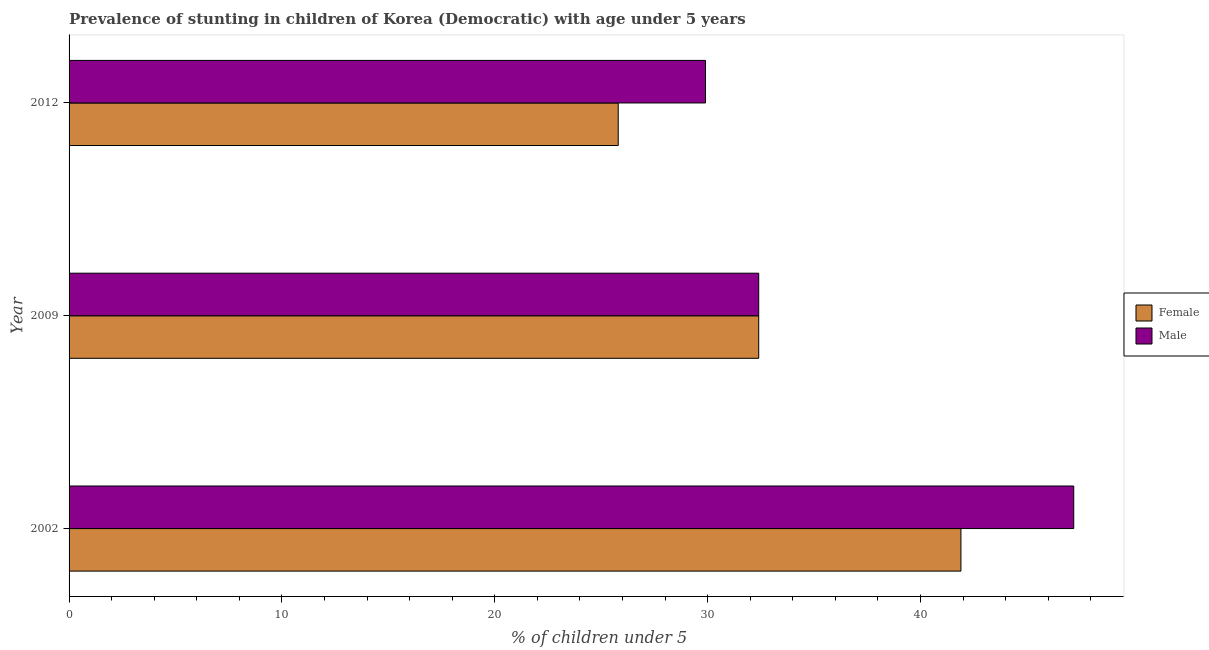How many groups of bars are there?
Keep it short and to the point. 3. Are the number of bars on each tick of the Y-axis equal?
Offer a very short reply. Yes. How many bars are there on the 2nd tick from the bottom?
Keep it short and to the point. 2. What is the label of the 1st group of bars from the top?
Offer a very short reply. 2012. In how many cases, is the number of bars for a given year not equal to the number of legend labels?
Your answer should be compact. 0. What is the percentage of stunted male children in 2009?
Offer a terse response. 32.4. Across all years, what is the maximum percentage of stunted female children?
Your answer should be very brief. 41.9. Across all years, what is the minimum percentage of stunted female children?
Ensure brevity in your answer.  25.8. In which year was the percentage of stunted male children maximum?
Keep it short and to the point. 2002. In which year was the percentage of stunted female children minimum?
Provide a succinct answer. 2012. What is the total percentage of stunted male children in the graph?
Your answer should be very brief. 109.5. What is the difference between the percentage of stunted male children in 2002 and that in 2012?
Your answer should be compact. 17.3. What is the difference between the percentage of stunted male children in 2009 and the percentage of stunted female children in 2012?
Your answer should be very brief. 6.6. What is the average percentage of stunted female children per year?
Offer a terse response. 33.37. What is the ratio of the percentage of stunted male children in 2002 to that in 2012?
Give a very brief answer. 1.58. Is the percentage of stunted female children in 2009 less than that in 2012?
Ensure brevity in your answer.  No. What is the difference between the highest and the second highest percentage of stunted male children?
Give a very brief answer. 14.8. What is the difference between the highest and the lowest percentage of stunted female children?
Give a very brief answer. 16.1. In how many years, is the percentage of stunted male children greater than the average percentage of stunted male children taken over all years?
Keep it short and to the point. 1. Is the sum of the percentage of stunted female children in 2002 and 2012 greater than the maximum percentage of stunted male children across all years?
Keep it short and to the point. Yes. What does the 1st bar from the bottom in 2002 represents?
Your response must be concise. Female. How many bars are there?
Offer a terse response. 6. How many years are there in the graph?
Your answer should be compact. 3. What is the difference between two consecutive major ticks on the X-axis?
Your answer should be very brief. 10. Does the graph contain any zero values?
Your response must be concise. No. Does the graph contain grids?
Offer a terse response. No. Where does the legend appear in the graph?
Offer a very short reply. Center right. What is the title of the graph?
Ensure brevity in your answer.  Prevalence of stunting in children of Korea (Democratic) with age under 5 years. What is the label or title of the X-axis?
Ensure brevity in your answer.   % of children under 5. What is the label or title of the Y-axis?
Give a very brief answer. Year. What is the  % of children under 5 of Female in 2002?
Your answer should be compact. 41.9. What is the  % of children under 5 of Male in 2002?
Offer a terse response. 47.2. What is the  % of children under 5 in Female in 2009?
Provide a short and direct response. 32.4. What is the  % of children under 5 of Male in 2009?
Your answer should be compact. 32.4. What is the  % of children under 5 of Female in 2012?
Make the answer very short. 25.8. What is the  % of children under 5 in Male in 2012?
Offer a terse response. 29.9. Across all years, what is the maximum  % of children under 5 in Female?
Keep it short and to the point. 41.9. Across all years, what is the maximum  % of children under 5 of Male?
Make the answer very short. 47.2. Across all years, what is the minimum  % of children under 5 in Female?
Provide a succinct answer. 25.8. Across all years, what is the minimum  % of children under 5 in Male?
Give a very brief answer. 29.9. What is the total  % of children under 5 of Female in the graph?
Your answer should be compact. 100.1. What is the total  % of children under 5 of Male in the graph?
Your answer should be compact. 109.5. What is the difference between the  % of children under 5 in Female in 2002 and the  % of children under 5 in Male in 2009?
Your answer should be very brief. 9.5. What is the difference between the  % of children under 5 in Female in 2002 and the  % of children under 5 in Male in 2012?
Your answer should be compact. 12. What is the average  % of children under 5 of Female per year?
Your response must be concise. 33.37. What is the average  % of children under 5 in Male per year?
Your response must be concise. 36.5. In the year 2012, what is the difference between the  % of children under 5 of Female and  % of children under 5 of Male?
Your response must be concise. -4.1. What is the ratio of the  % of children under 5 of Female in 2002 to that in 2009?
Offer a very short reply. 1.29. What is the ratio of the  % of children under 5 in Male in 2002 to that in 2009?
Your answer should be very brief. 1.46. What is the ratio of the  % of children under 5 in Female in 2002 to that in 2012?
Keep it short and to the point. 1.62. What is the ratio of the  % of children under 5 in Male in 2002 to that in 2012?
Provide a short and direct response. 1.58. What is the ratio of the  % of children under 5 of Female in 2009 to that in 2012?
Ensure brevity in your answer.  1.26. What is the ratio of the  % of children under 5 in Male in 2009 to that in 2012?
Give a very brief answer. 1.08. What is the difference between the highest and the second highest  % of children under 5 in Male?
Ensure brevity in your answer.  14.8. What is the difference between the highest and the lowest  % of children under 5 of Male?
Give a very brief answer. 17.3. 